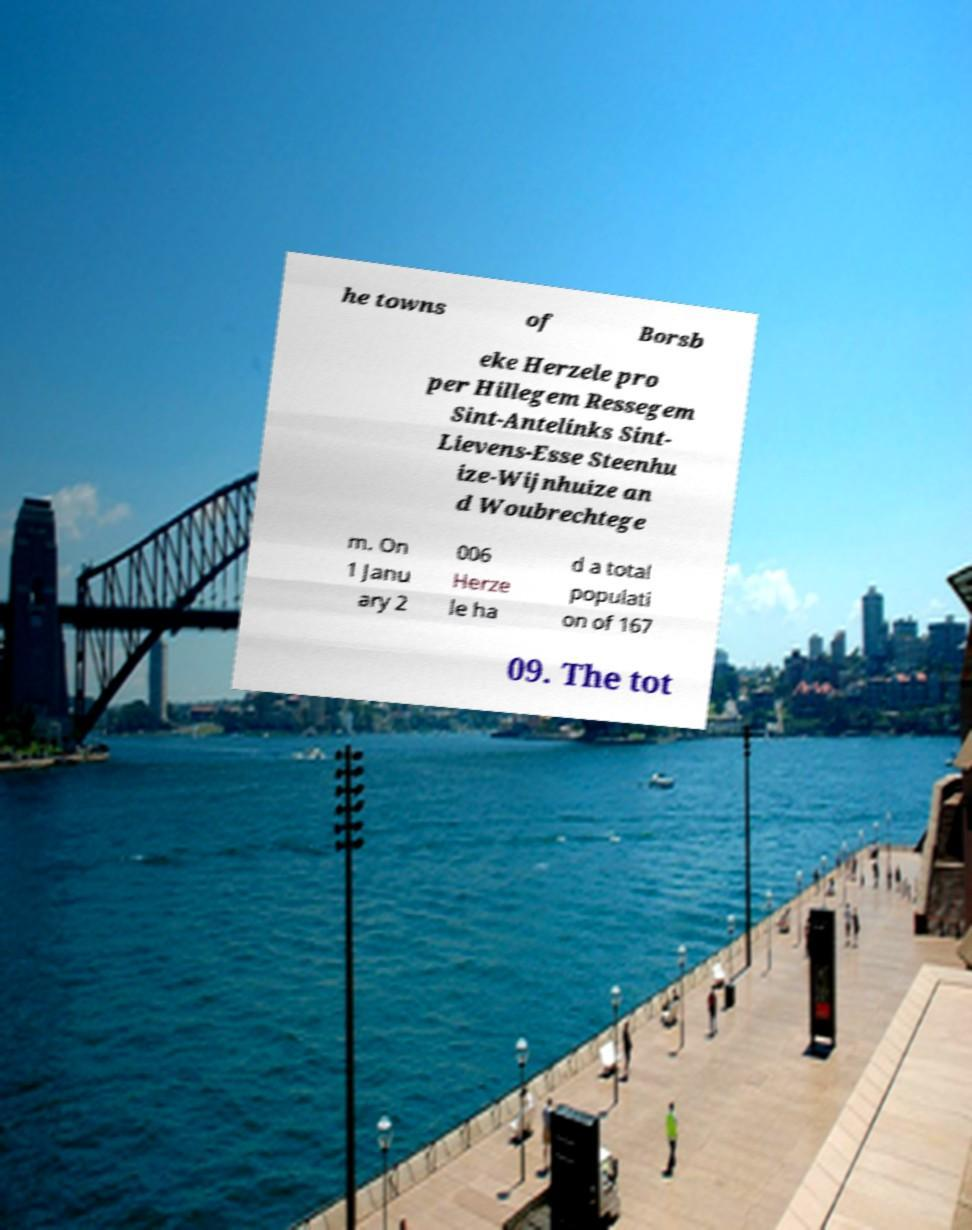Can you read and provide the text displayed in the image?This photo seems to have some interesting text. Can you extract and type it out for me? he towns of Borsb eke Herzele pro per Hillegem Ressegem Sint-Antelinks Sint- Lievens-Esse Steenhu ize-Wijnhuize an d Woubrechtege m. On 1 Janu ary 2 006 Herze le ha d a total populati on of 167 09. The tot 